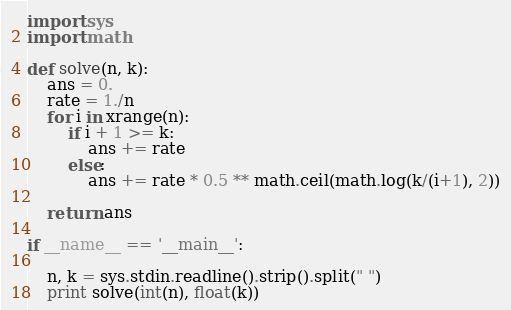Convert code to text. <code><loc_0><loc_0><loc_500><loc_500><_Python_>import sys
import math

def solve(n, k):
    ans = 0.
    rate = 1./n
    for i in xrange(n):
        if i + 1 >= k:
            ans += rate
        else:
            ans += rate * 0.5 ** math.ceil(math.log(k/(i+1), 2))

    return ans

if __name__ == '__main__':

    n, k = sys.stdin.readline().strip().split(" ")
    print solve(int(n), float(k))</code> 